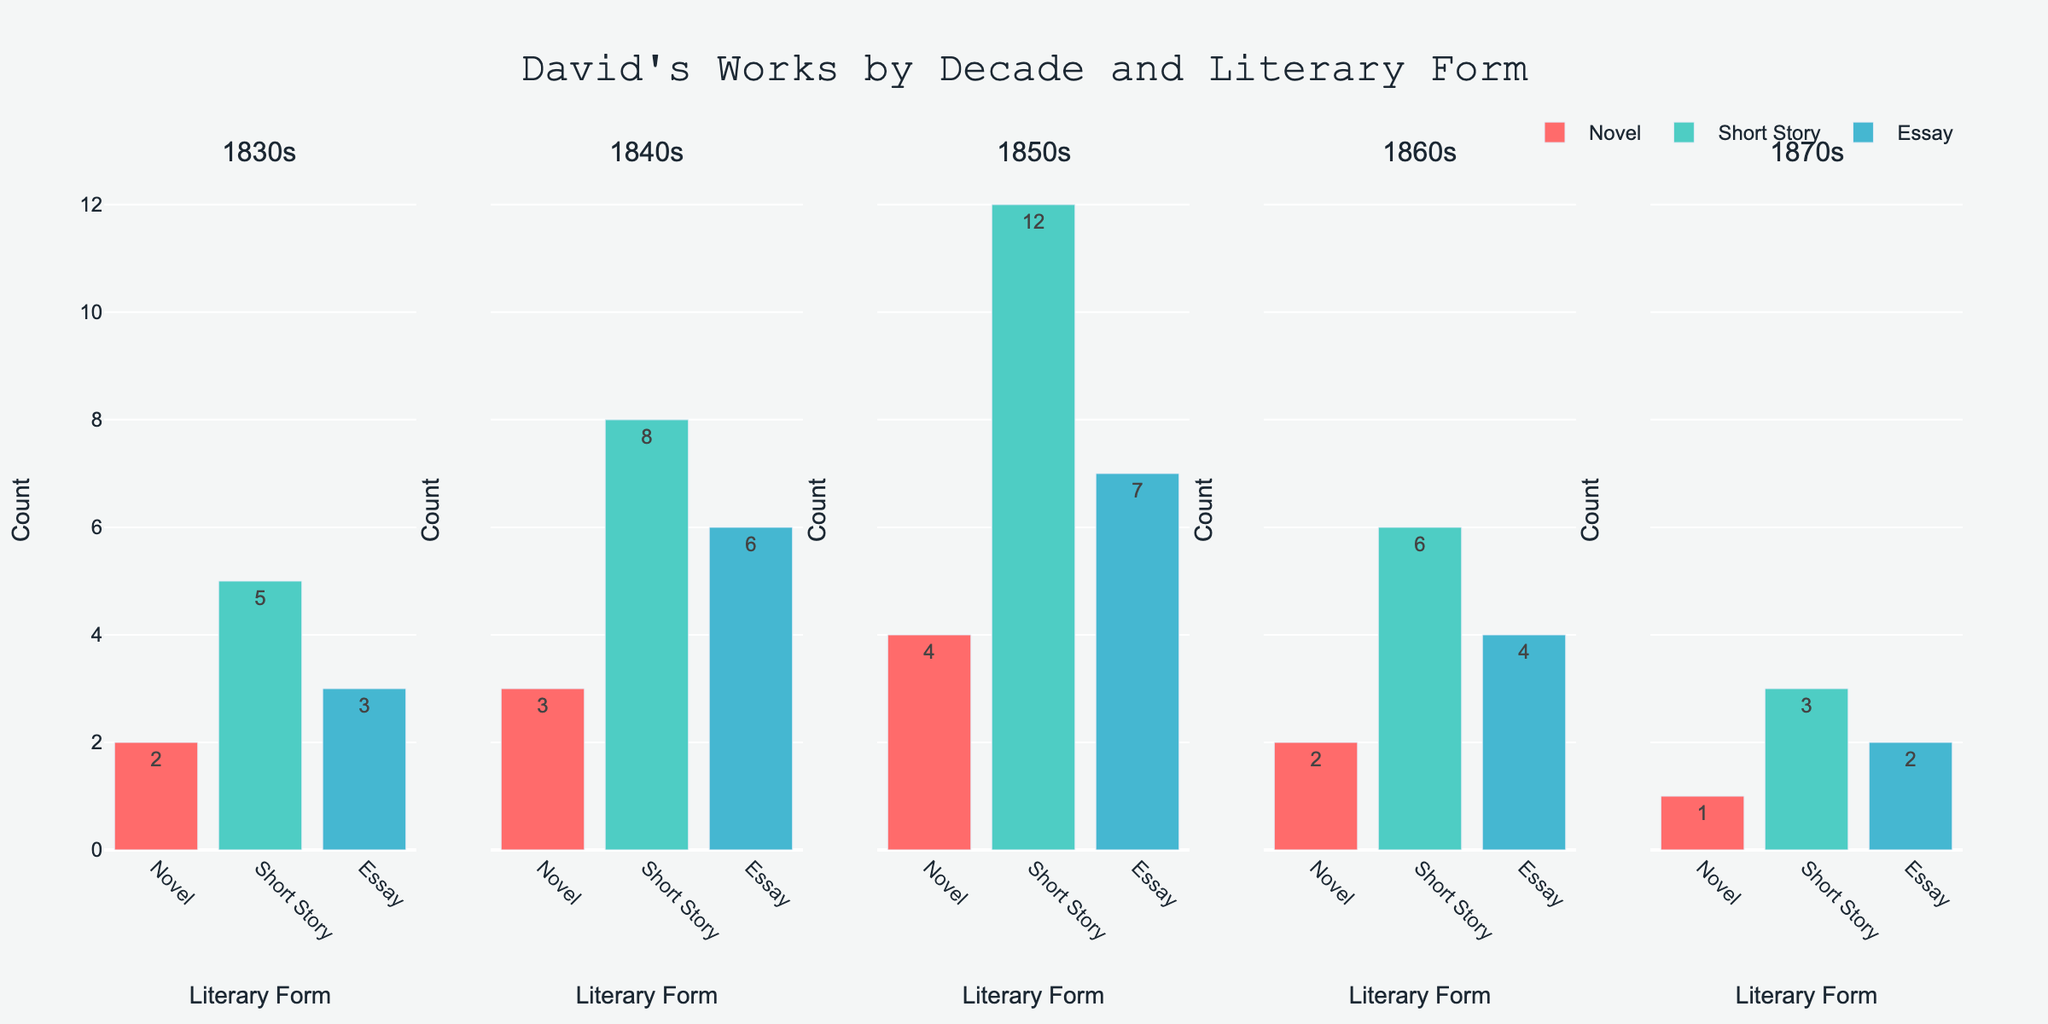How many novels were published in the 1850s? To find the number of novels published in the 1850s, look at the bar corresponding to the "Novel" category in the 1850s subplot. The bar height and text label indicate the count.
Answer: 4 Which decade had the highest number of short stories published? Compare the heights and text labels of the bars representing "Short Story" across all subplots. The decade with the highest value is the one with the tallest bar and largest number.
Answer: 1850s What is the total number of works published in the 1830s? Sum the counts of all literary forms (Novel, Short Story, Essay) in the 1830s subplot: 2 (Novel) + 5 (Short Story) + 3 (Essay).
Answer: 10 How many more essays were published in the 1840s compared to the 1870s? Subtract the number of essays in the 1870s from the number in the 1840s. From the 1840s subplot, the count is 6; from the 1870s subplot, the count is 2. The difference is 6 - 2.
Answer: 4 What is the average number of published works across all literary forms in the 1860s? Sum the counts of Novel (2), Short Story (6), and Essay (4) in the 1860s subplot and divide by the number of forms (3). The calculation is (2 + 6 + 4) / 3.
Answer: 4 Which literary form was consistently published in every decade? Check each subplot for the presence of bars for each form. The form that appears in all subplots (1830s, 1840s, 1850s, 1860s, 1870s) is "Short Story".
Answer: Short Story In which decade did the number of novels published peak? Compare the heights and text labels of the "Novel" bars across all subplots. The highest count is observed in the 1850s subplot.
Answer: 1850s How many total essays were published between 1830 and 1870? Sum the counts of essays from each decade: 1830s (3) + 1840s (6) + 1850s (7) + 1860s (4) + 1870s (2). The calculation is 3 + 6 + 7 + 4 + 2.
Answer: 22 Which decade saw the lowest number of published works in total? Sum the counts for all literary forms in each decade and compare. The 1870s have the lowest total with 1 (Novel) + 3 (Short Story) + 2 (Essay).
Answer: 6 How does the count of short stories in the 1860s compare to the count of essays in the same decade? Compare the heights and text labels of the "Short Story" and "Essay" bars in the 1860s subplot. Short stories have a count of 6, and essays have a count of 4.
Answer: More short stories than essays, by 2 